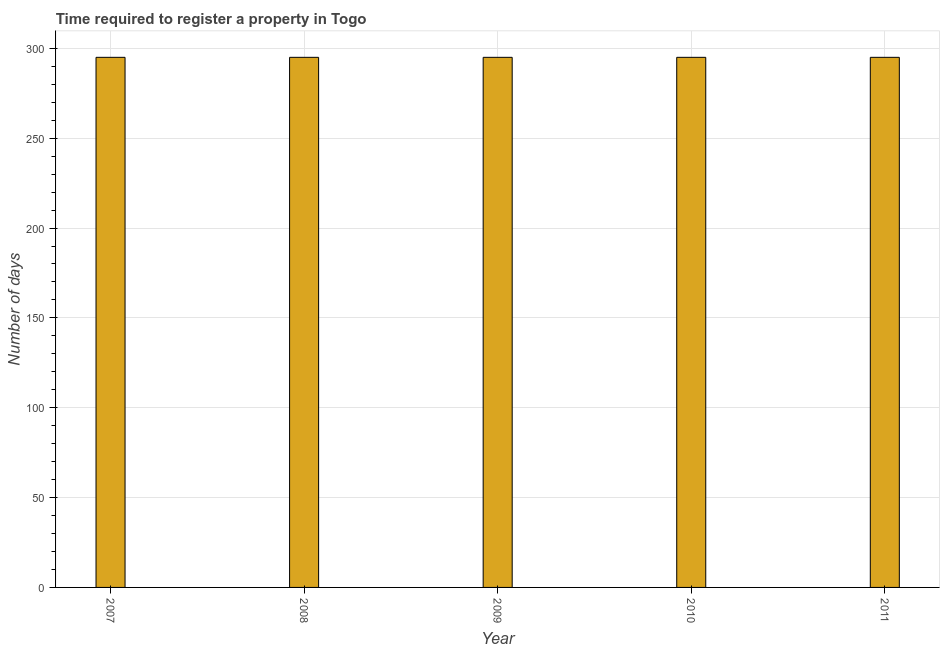What is the title of the graph?
Provide a succinct answer. Time required to register a property in Togo. What is the label or title of the X-axis?
Provide a short and direct response. Year. What is the label or title of the Y-axis?
Provide a succinct answer. Number of days. What is the number of days required to register property in 2008?
Offer a very short reply. 295. Across all years, what is the maximum number of days required to register property?
Make the answer very short. 295. Across all years, what is the minimum number of days required to register property?
Offer a very short reply. 295. What is the sum of the number of days required to register property?
Provide a short and direct response. 1475. What is the average number of days required to register property per year?
Your answer should be very brief. 295. What is the median number of days required to register property?
Make the answer very short. 295. In how many years, is the number of days required to register property greater than 70 days?
Offer a very short reply. 5. What is the ratio of the number of days required to register property in 2008 to that in 2010?
Keep it short and to the point. 1. Is the difference between the number of days required to register property in 2008 and 2010 greater than the difference between any two years?
Provide a succinct answer. Yes. How many bars are there?
Provide a succinct answer. 5. How many years are there in the graph?
Offer a terse response. 5. What is the Number of days of 2007?
Your response must be concise. 295. What is the Number of days in 2008?
Provide a short and direct response. 295. What is the Number of days in 2009?
Provide a succinct answer. 295. What is the Number of days in 2010?
Your answer should be very brief. 295. What is the Number of days of 2011?
Give a very brief answer. 295. What is the difference between the Number of days in 2007 and 2010?
Offer a very short reply. 0. What is the difference between the Number of days in 2007 and 2011?
Provide a short and direct response. 0. What is the difference between the Number of days in 2008 and 2010?
Provide a succinct answer. 0. What is the difference between the Number of days in 2009 and 2010?
Your answer should be very brief. 0. What is the difference between the Number of days in 2009 and 2011?
Provide a short and direct response. 0. What is the ratio of the Number of days in 2007 to that in 2009?
Offer a terse response. 1. What is the ratio of the Number of days in 2007 to that in 2010?
Your answer should be very brief. 1. What is the ratio of the Number of days in 2007 to that in 2011?
Provide a succinct answer. 1. What is the ratio of the Number of days in 2008 to that in 2011?
Give a very brief answer. 1. 